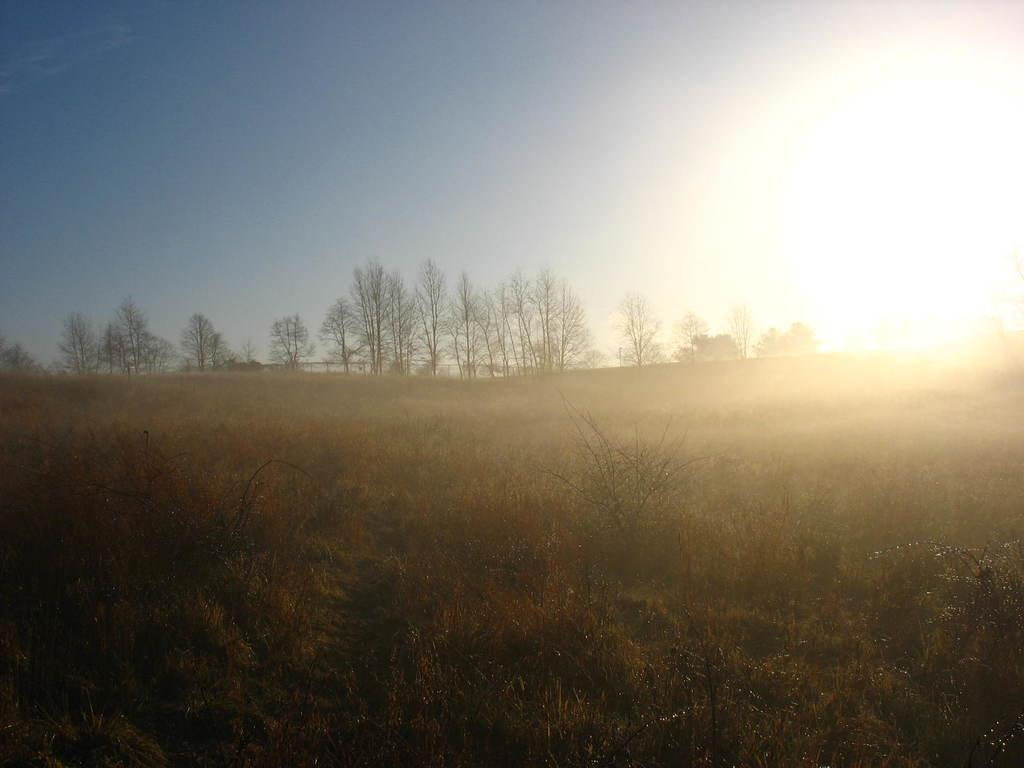What is covering the ground in the image? The ground in the image is covered with dry plants. How many trees can be seen in the image? There are many trees in the image. Is there any cream visible on the trees in the image? There is no cream present on the trees in the image. Can you confirm the existence of snails in the image? There is no mention of snails in the provided facts, so we cannot confirm their existence in the image. 